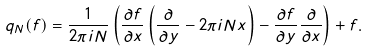<formula> <loc_0><loc_0><loc_500><loc_500>\ q _ { N } ( f ) = \frac { 1 } { 2 \pi i N } \left ( \frac { \partial f } { \partial x } \left ( \frac { \partial } { \partial y } - 2 \pi i N x \right ) - \frac { \partial f } { \partial y } \frac { \partial } { \partial x } \right ) + f .</formula> 